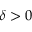Convert formula to latex. <formula><loc_0><loc_0><loc_500><loc_500>\delta > 0</formula> 